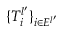Convert formula to latex. <formula><loc_0><loc_0><loc_500><loc_500>\{ T _ { i } ^ { l ^ { \prime } } \} _ { i \in E ^ { l ^ { \prime } } }</formula> 